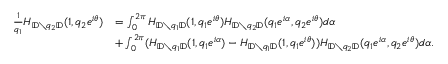Convert formula to latex. <formula><loc_0><loc_0><loc_500><loc_500>\begin{array} { r l } { \frac { 1 } { q _ { 1 } } H _ { { \mathbb { D } } \ q _ { 2 } { \mathbb { D } } } ( 1 , q _ { 2 } e ^ { i \theta } ) } & { = \int _ { 0 } ^ { 2 \pi } H _ { { \mathbb { D } } \ q _ { 1 } { \mathbb { D } } } ( 1 , q _ { 1 } e ^ { i \theta } ) H _ { { \mathbb { D } } \ q _ { 2 } { \mathbb { D } } } ( q _ { 1 } e ^ { i \alpha } , q _ { 2 } e ^ { i \theta } ) d \alpha } \\ & { + \int _ { 0 } ^ { 2 \pi } ( H _ { { \mathbb { D } } \ q _ { 1 } { \mathbb { D } } } ( 1 , q _ { 1 } e ^ { i \alpha } ) - H _ { { \mathbb { D } } \ q _ { 1 } { \mathbb { D } } } ( 1 , q _ { 1 } e ^ { i \theta } ) ) H _ { { \mathbb { D } } \ q _ { 2 } { \mathbb { D } } } ( q _ { 1 } e ^ { i \alpha } , q _ { 2 } e ^ { i \theta } ) d \alpha . } \end{array}</formula> 